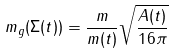<formula> <loc_0><loc_0><loc_500><loc_500>m _ { g } ( \Sigma ( t ) ) = \frac { m } { m ( t ) } \sqrt { \frac { A ( t ) } { 1 6 \pi } }</formula> 